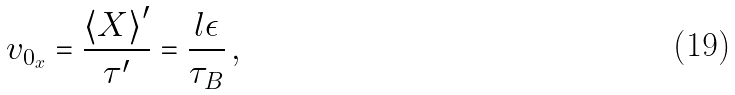Convert formula to latex. <formula><loc_0><loc_0><loc_500><loc_500>v _ { 0 _ { x } } = \frac { { \langle X \rangle } ^ { \prime } } { \tau ^ { \prime } } = \frac { l \epsilon } { \tau _ { B } } \, ,</formula> 